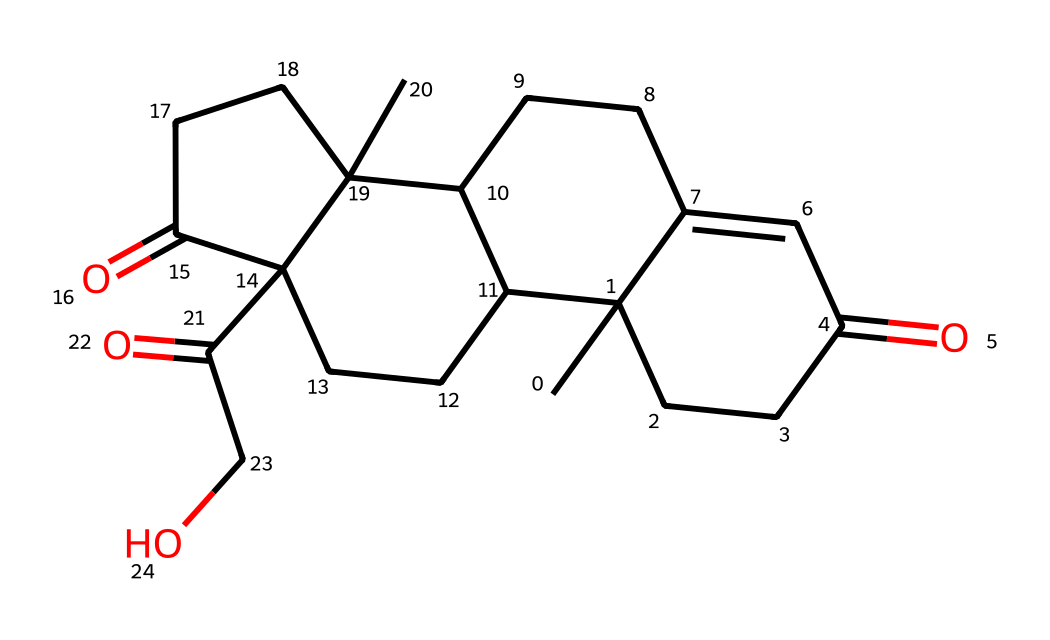What is the molecular formula of cortisol? To determine the molecular formula from the SMILES representation, we can count the occurrences of each atom. The given structure includes 21 carbon atoms (C), 30 hydrogen atoms (H), and 5 oxygen atoms (O), leading to the molecular formula C21H30O5.
Answer: C21H30O5 How many rings are present in the structure of cortisol? Observing the SMILES representation, we identify multiple cycles in the structure denoted by the digits. There are four distinct rings which can be counted from the labeling: 1, 2, 3, and 4 indicating the ring closures.
Answer: 4 What functional groups are present in the structure of cortisol? Analyzing the structure, we can identify that cortisol contains ketone groups (C=O) and a hydroxyl group (-OH). The visible C=O and -OH indicate the presence of these specific functional groups.
Answer: ketone, hydroxyl How does the steroid structure relate to cortisol's function as a hormone? Cortisol has a steroid backbone which is essential for its biological activity as a hormone. This steroid structure enables cortisol to interact with steroid hormone receptors, governing a variety of physiological responses, including stress and metabolism regulation.
Answer: steroid structure What type of hormone category does cortisol belong to? Cortisol is classified as a glucocorticoid hormone, which is a type of steroid hormone produced by the adrenal cortex. Its structure is consistent with the properties of glucocorticoids, influencing glucose metabolism and immune response.
Answer: glucocorticoid What is the role of the hydroxyl group in cortisol? The hydroxyl group (-OH) in cortisol enhances its solubility in water and contributes to its interaction with specific receptors in the body. This functional feature is vital for its effectiveness as an active hormone in metabolic processes.
Answer: enhances solubility 